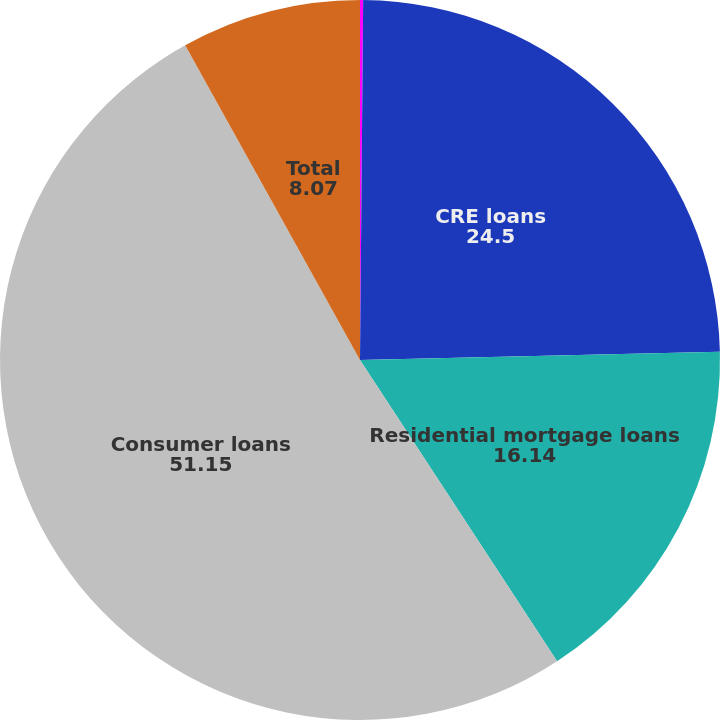Convert chart to OTSL. <chart><loc_0><loc_0><loc_500><loc_500><pie_chart><fcel>C&I loans<fcel>CRE loans<fcel>Residential mortgage loans<fcel>Consumer loans<fcel>Total<nl><fcel>0.14%<fcel>24.5%<fcel>16.14%<fcel>51.15%<fcel>8.07%<nl></chart> 